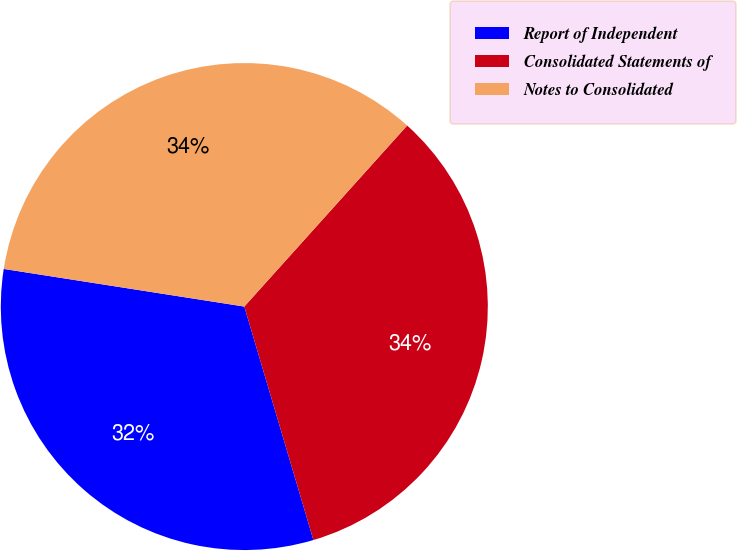Convert chart. <chart><loc_0><loc_0><loc_500><loc_500><pie_chart><fcel>Report of Independent<fcel>Consolidated Statements of<fcel>Notes to Consolidated<nl><fcel>32.05%<fcel>33.76%<fcel>34.19%<nl></chart> 